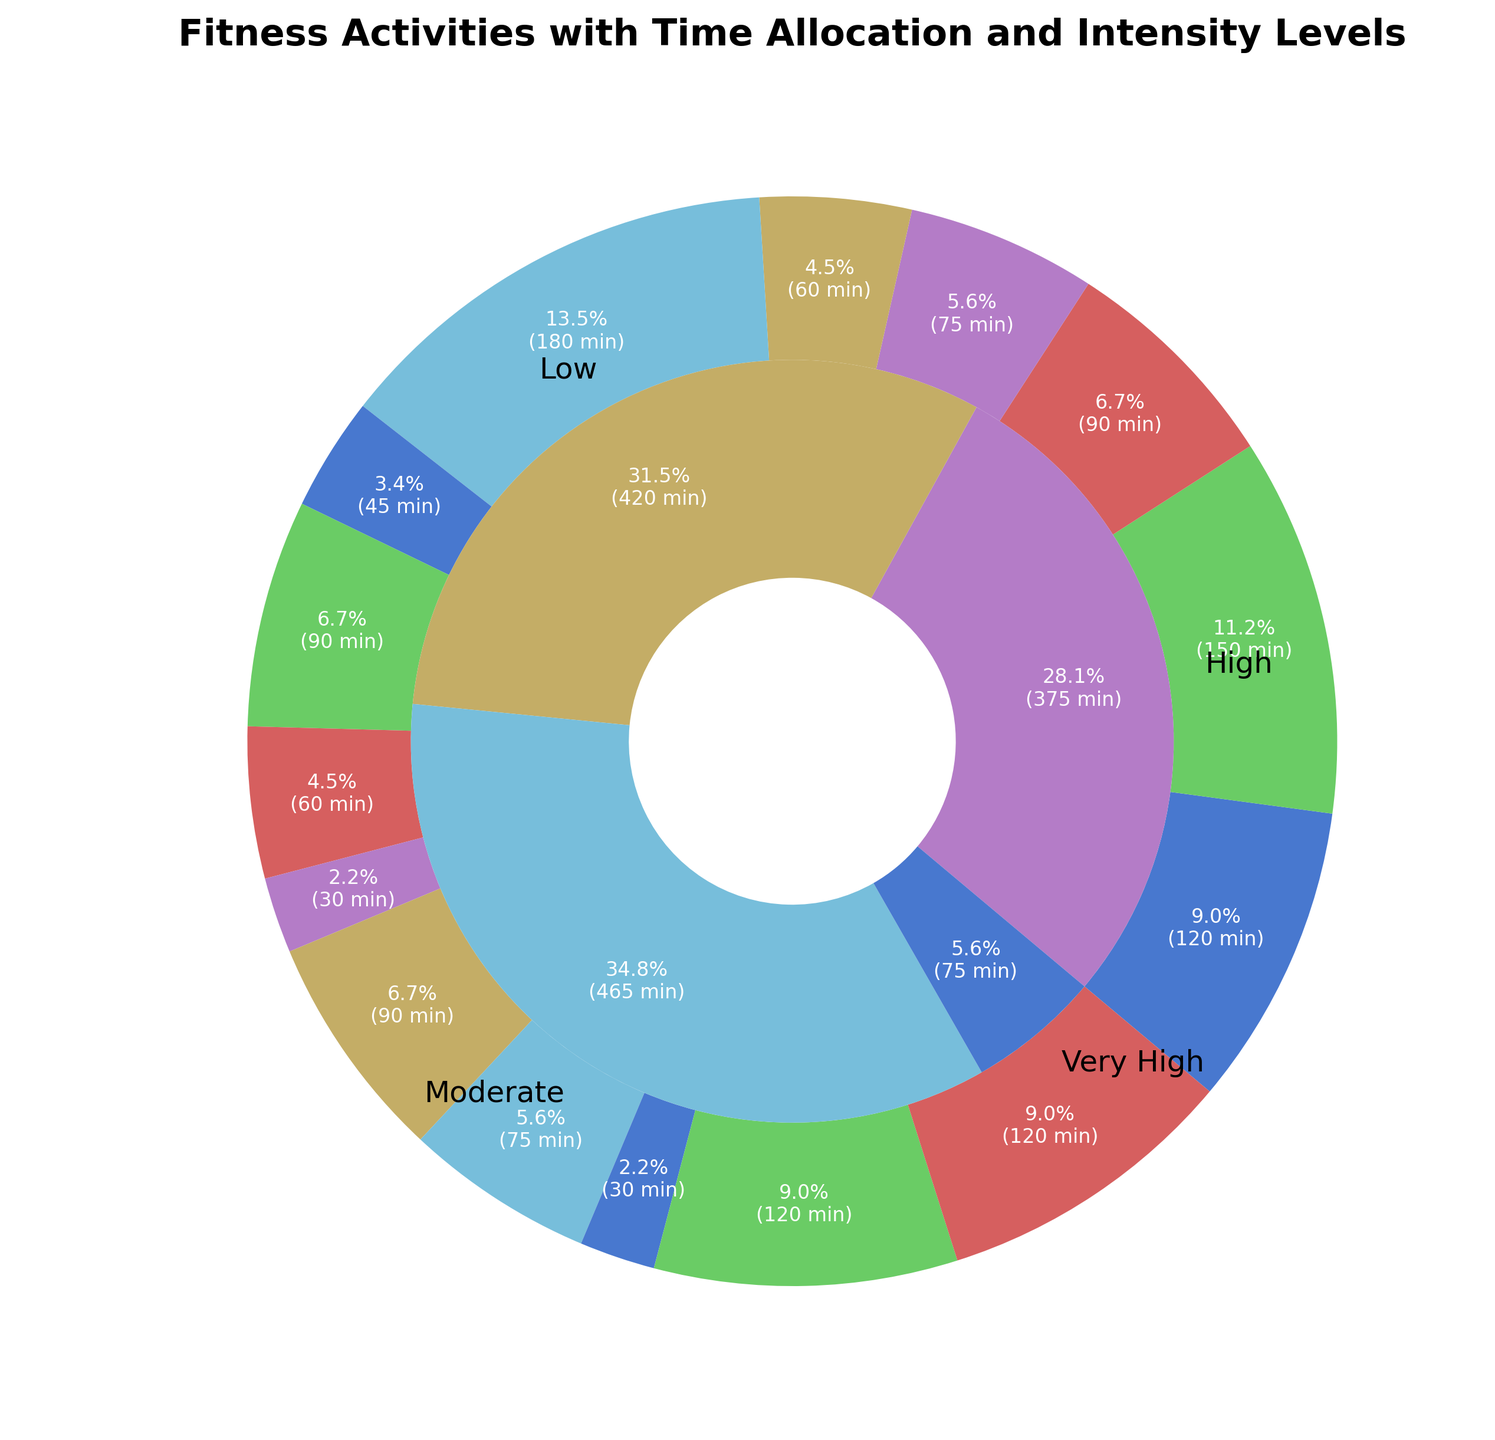Which activity has the highest time allocation? By observing the outer ring of the nested pie chart, which represents different fitness activities, identify the activity that has the largest segment.
Answer: Walking Which intensity level has the lowest time allocation? Look at the inner ring of the pie chart, which represents different intensity levels. Identify the segment with the smallest area.
Answer: Very High How much total time is allocated to activities with high intensity? Find the 'High' intensity segment in the inner ring and sum up the corresponding time allocations in the outer ring: Running (150) + Weightlifting (75) + Swimming (60) + Rock Climbing (60) + Jumping Rope (30). The total is 150 + 75 + 60 + 60 + 30 = 375 minutes.
Answer: 375 minutes How does the time allocated to moderate intensity activities compare to high intensity activities? First, sum the time allocation for 'Moderate' intensity: Cycling (90) + Pilates (90) + Tennis (90) + Dancing (75) + Hiking (120). Total is 90 + 90 + 90 + 75 + 120 = 465 minutes. Then compare it to the sum of 'High' intensity activities, which is 375 minutes. 465 is greater than 375.
Answer: Moderate intensity > High intensity What percentage of total time is spent on Very High intensity activities? Very High intensity includes HIIT (45) + Rowing (30). First, sum the total time for Very High intensity: 45 + 30 = 75 minutes. Then, sum the total time for all activities: 120 + 150 + 90 + 75 + 60 + 180 + 45 + 90 + 60 + 30 + 90 + 75 + 30 + 120 + 120 = 1335 minutes. The percentage is (75/1335) * 100 = 5.62%.
Answer: 5.6% What is the combined time allocation of Yoga and Stretching? Find the time allocations for Yoga (120) and Stretching (120) and sum them up: 120 + 120 = 240 minutes.
Answer: 240 minutes Which has more time allocated, cycling or dancing? Look at the outer ring for the segments representing cycling (90 minutes) and dancing (75 minutes). Cycling has more time allocated.
Answer: Cycling What is the time difference between the activity with the highest allocation and the activity with the lowest allocation? The highest allocation is Walking (180 minutes) and the lowest is a tie between Rowing and Jumping Rope (both 30 minutes). The difference is 180 - 30 = 150 minutes.
Answer: 150 minutes How does the segment size for low intensity compare to moderate intensity on the inner ring? Observe the inner ring of the pie chart. Visually assess the size of the segment for Low intensity (containing Yoga, Walking, and Stretching) compared to Moderate intensity (containing Cycling, Pilates, Tennis, Dancing, Hiking). Moderate intensity has a larger segment.
Answer: Moderate intensity > Low intensity What percentage of time is spent on Walking alone? Walking is represented by its own segment in the outer ring. To calculate this percentage, take the time allocated to Walking (180 minutes) and divide by the total time allocation (1335 minutes), then multiply by 100. (180/1335) * 100 = 13.5%.
Answer: 13.5% 